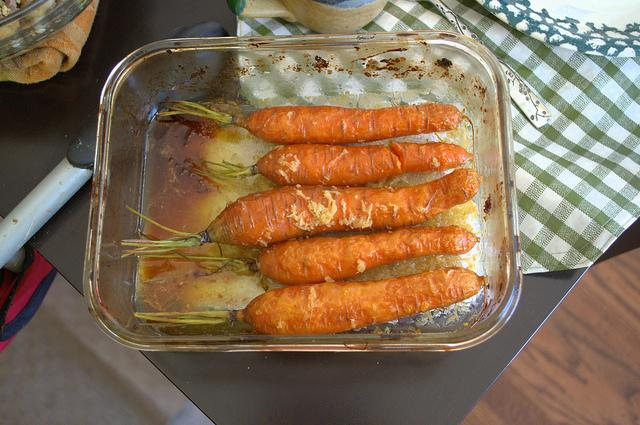Where did the food in the dish come from? Please explain your reasoning. ground. Carrots grow in the dirt. 